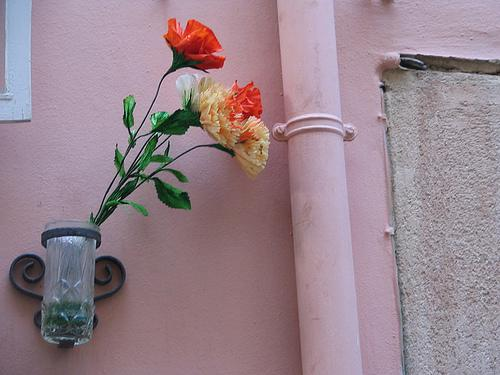Question: where was this photo taken?
Choices:
A. An alley.
B. Along a building.
C. Under a bridge.
D. An old train.
Answer with the letter. Answer: B Question: where are the flowers?
Choices:
A. In a window.
B. In a field.
C. On the ground.
D. Outside of a building.
Answer with the letter. Answer: D Question: how many flowers are in the photo?
Choices:
A. Five.
B. Six.
C. Four.
D. Three.
Answer with the letter. Answer: A Question: what colors are the flowers in the photo?
Choices:
A. Blue, red and white.
B. Orange, red and white.
C. White, orange and yellow.
D. Purple, white and yellow.
Answer with the letter. Answer: C Question: what are the flowers in?
Choices:
A. A bottle.
B. A jar.
C. A vase.
D. A cup.
Answer with the letter. Answer: C Question: how many people are in the photo?
Choices:
A. Three.
B. None.
C. Two.
D. One.
Answer with the letter. Answer: B 